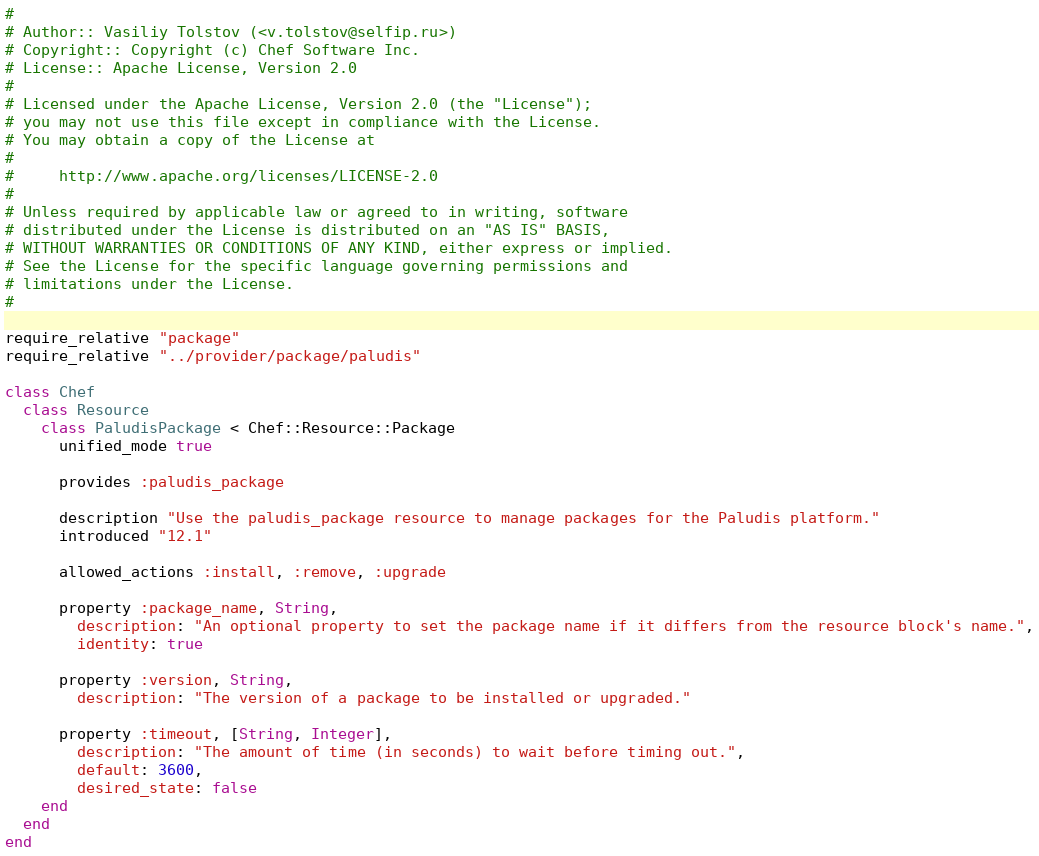Convert code to text. <code><loc_0><loc_0><loc_500><loc_500><_Ruby_>#
# Author:: Vasiliy Tolstov (<v.tolstov@selfip.ru>)
# Copyright:: Copyright (c) Chef Software Inc.
# License:: Apache License, Version 2.0
#
# Licensed under the Apache License, Version 2.0 (the "License");
# you may not use this file except in compliance with the License.
# You may obtain a copy of the License at
#
#     http://www.apache.org/licenses/LICENSE-2.0
#
# Unless required by applicable law or agreed to in writing, software
# distributed under the License is distributed on an "AS IS" BASIS,
# WITHOUT WARRANTIES OR CONDITIONS OF ANY KIND, either express or implied.
# See the License for the specific language governing permissions and
# limitations under the License.
#

require_relative "package"
require_relative "../provider/package/paludis"

class Chef
  class Resource
    class PaludisPackage < Chef::Resource::Package
      unified_mode true

      provides :paludis_package

      description "Use the paludis_package resource to manage packages for the Paludis platform."
      introduced "12.1"

      allowed_actions :install, :remove, :upgrade

      property :package_name, String,
        description: "An optional property to set the package name if it differs from the resource block's name.",
        identity: true

      property :version, String,
        description: "The version of a package to be installed or upgraded."

      property :timeout, [String, Integer],
        description: "The amount of time (in seconds) to wait before timing out.",
        default: 3600,
        desired_state: false
    end
  end
end
</code> 